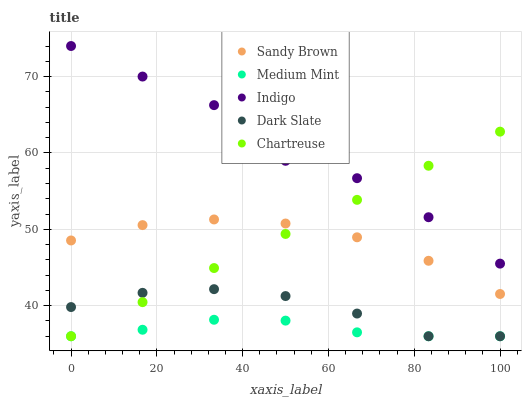Does Medium Mint have the minimum area under the curve?
Answer yes or no. Yes. Does Indigo have the maximum area under the curve?
Answer yes or no. Yes. Does Chartreuse have the minimum area under the curve?
Answer yes or no. No. Does Chartreuse have the maximum area under the curve?
Answer yes or no. No. Is Chartreuse the smoothest?
Answer yes or no. Yes. Is Indigo the roughest?
Answer yes or no. Yes. Is Indigo the smoothest?
Answer yes or no. No. Is Chartreuse the roughest?
Answer yes or no. No. Does Medium Mint have the lowest value?
Answer yes or no. Yes. Does Indigo have the lowest value?
Answer yes or no. No. Does Indigo have the highest value?
Answer yes or no. Yes. Does Chartreuse have the highest value?
Answer yes or no. No. Is Medium Mint less than Indigo?
Answer yes or no. Yes. Is Sandy Brown greater than Dark Slate?
Answer yes or no. Yes. Does Chartreuse intersect Medium Mint?
Answer yes or no. Yes. Is Chartreuse less than Medium Mint?
Answer yes or no. No. Is Chartreuse greater than Medium Mint?
Answer yes or no. No. Does Medium Mint intersect Indigo?
Answer yes or no. No. 